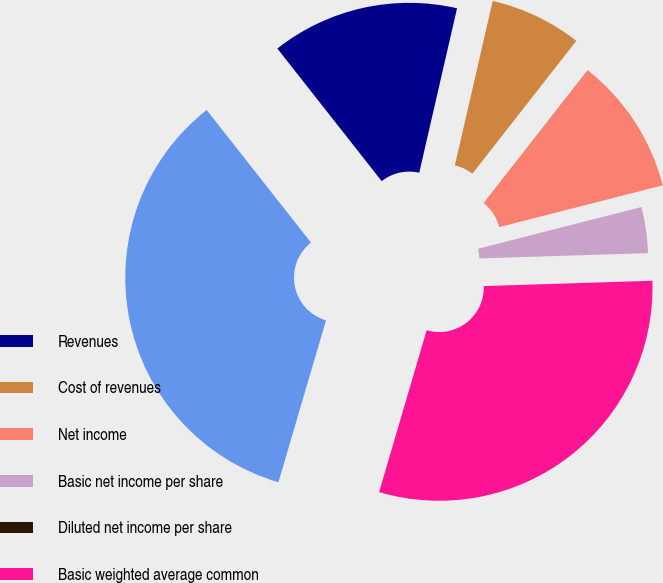Convert chart. <chart><loc_0><loc_0><loc_500><loc_500><pie_chart><fcel>Revenues<fcel>Cost of revenues<fcel>Net income<fcel>Basic net income per share<fcel>Diluted net income per share<fcel>Basic weighted average common<fcel>Diluted weighted average<nl><fcel>14.21%<fcel>6.97%<fcel>10.45%<fcel>3.48%<fcel>0.0%<fcel>30.05%<fcel>34.84%<nl></chart> 